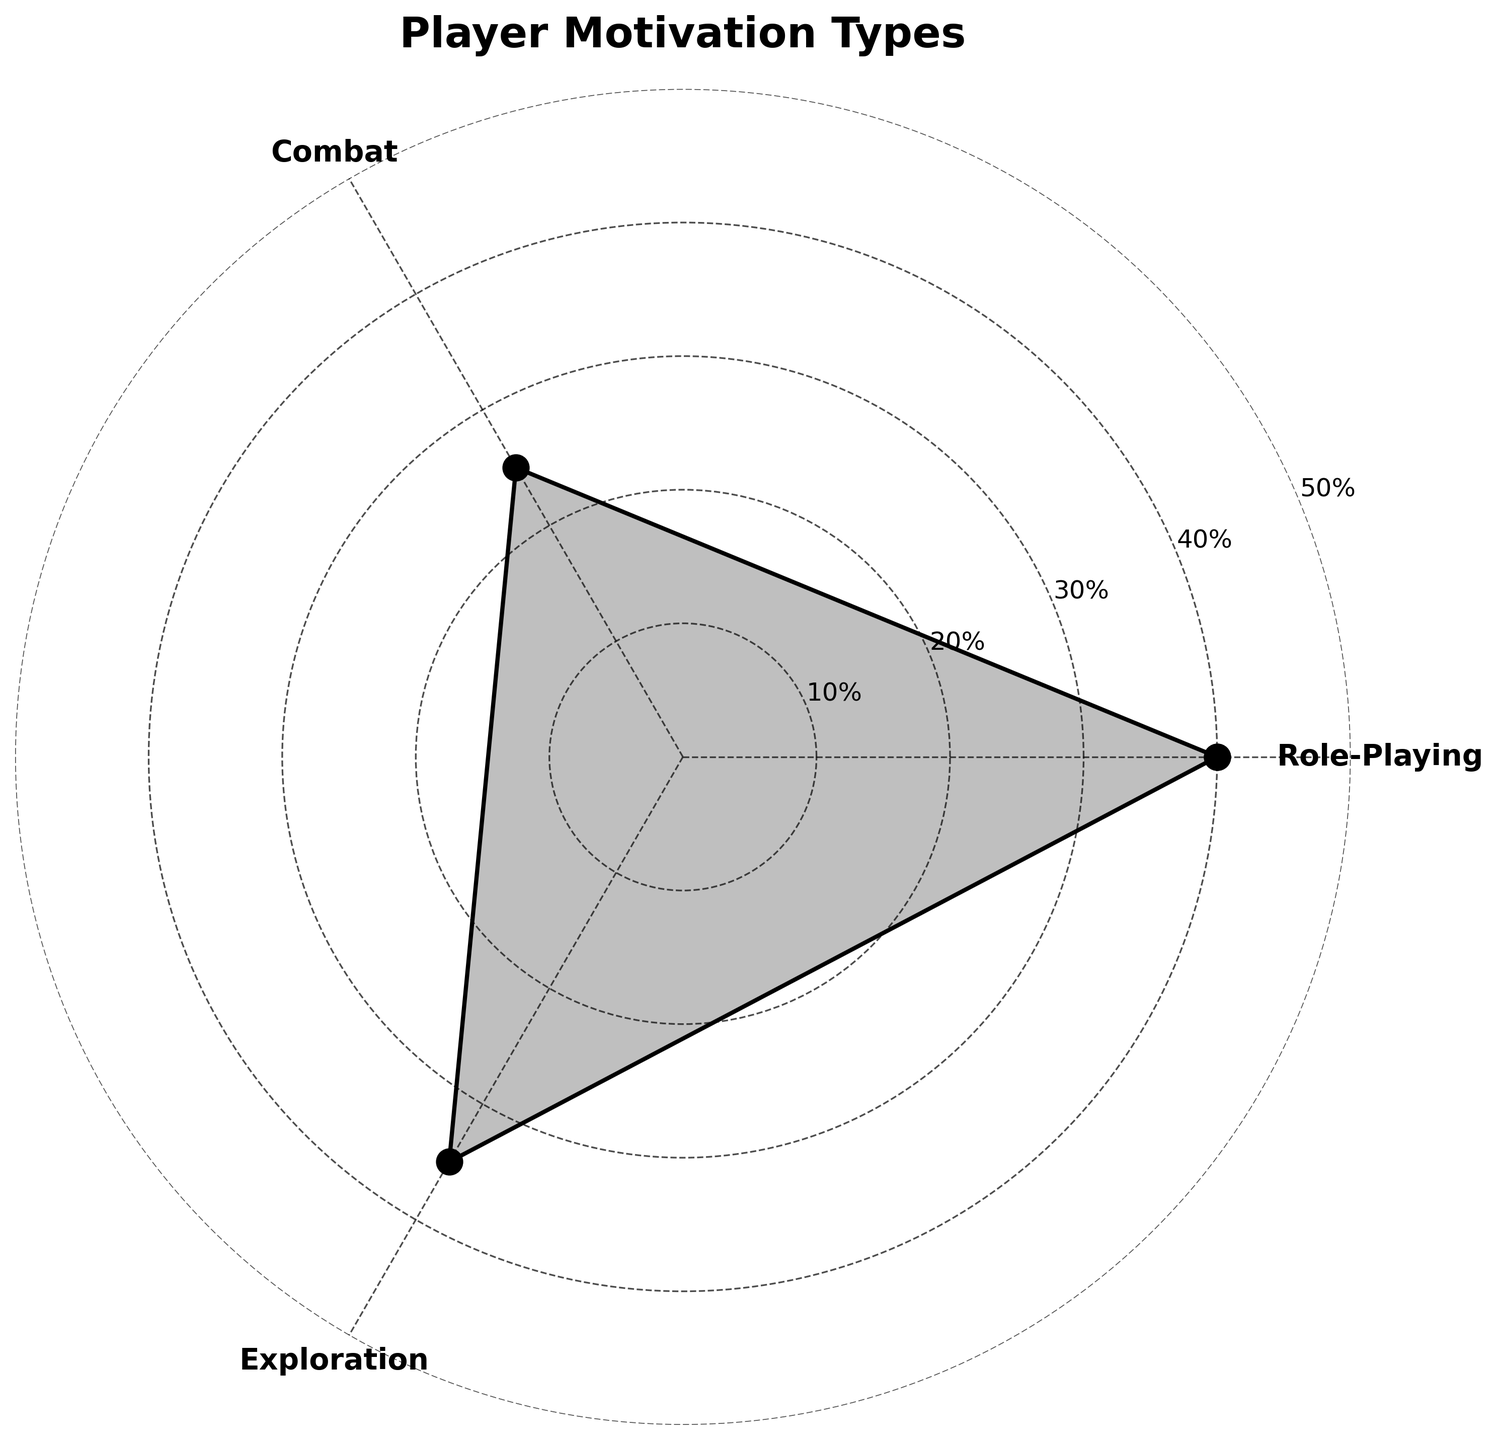What's the title of the chart? The title of the chart is usually placed at the top and in this case, it is clearly stated with large and bold text.
Answer: Player Motivation Types How many segments or groups are represented in the chart? The chart visually presents three distinct groups, which are labeled accordingly.
Answer: 3 Which group has the highest percentage? By examining each segment, one can see that Role-Playing has the largest radial distance, indicating the highest value.
Answer: Role-Playing What is the percentage value for the Combat group? Referring to the labeled radial extent of Combat, it indicates a percentage value.
Answer: 25% By how much does Role-Playing's percentage exceed Combat's? Role-Playing has a percentage of 40 and Combat has a percentage of 25. Subtracting Combat's value from Role-Playing's value gives 40 - 25.
Answer: 15 What is the average percentage of all groups? Summing the percentages: 40 (Role-Playing) + 25 (Combat) + 35 (Exploration) = 100. Dividing by the number of groups (3) gives the average.
Answer: 100 / 3 = 33.33 Which two groups' percentages total closest to 60? Adding the percentages of different group combinations: Role-Playing (40) + Combat (25) = 65, Combat (25) + Exploration (35) = 60, and Role-Playing (40) + Exploration (35) = 75. Hence, Combat and Exploration total exactly 60.
Answer: Combat and Exploration How much more is Exploration's percentage compared to Combat's? Exploration has a percentage of 35 and Combat has a percentage of 25. Subtracting Combat's from Exploration's gives 35 - 25.
Answer: 10 Which group values are less than the average percentage? The average percentage calculated is 33.33. Percentages of Combat and Exploration are compared to this value. Combat (25) is less than 33.33, but Exploration (35) and Role-Playing (40) are not.
Answer: Combat By what percentage does the sum of Role-Playing and Combat differ from 100%? Adding Role-Playing (40) and Combat (25) equals 65. Subtracting this sum from 100 gives 100 - 65.
Answer: 35 